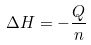Convert formula to latex. <formula><loc_0><loc_0><loc_500><loc_500>\Delta H = - \frac { Q } { n }</formula> 